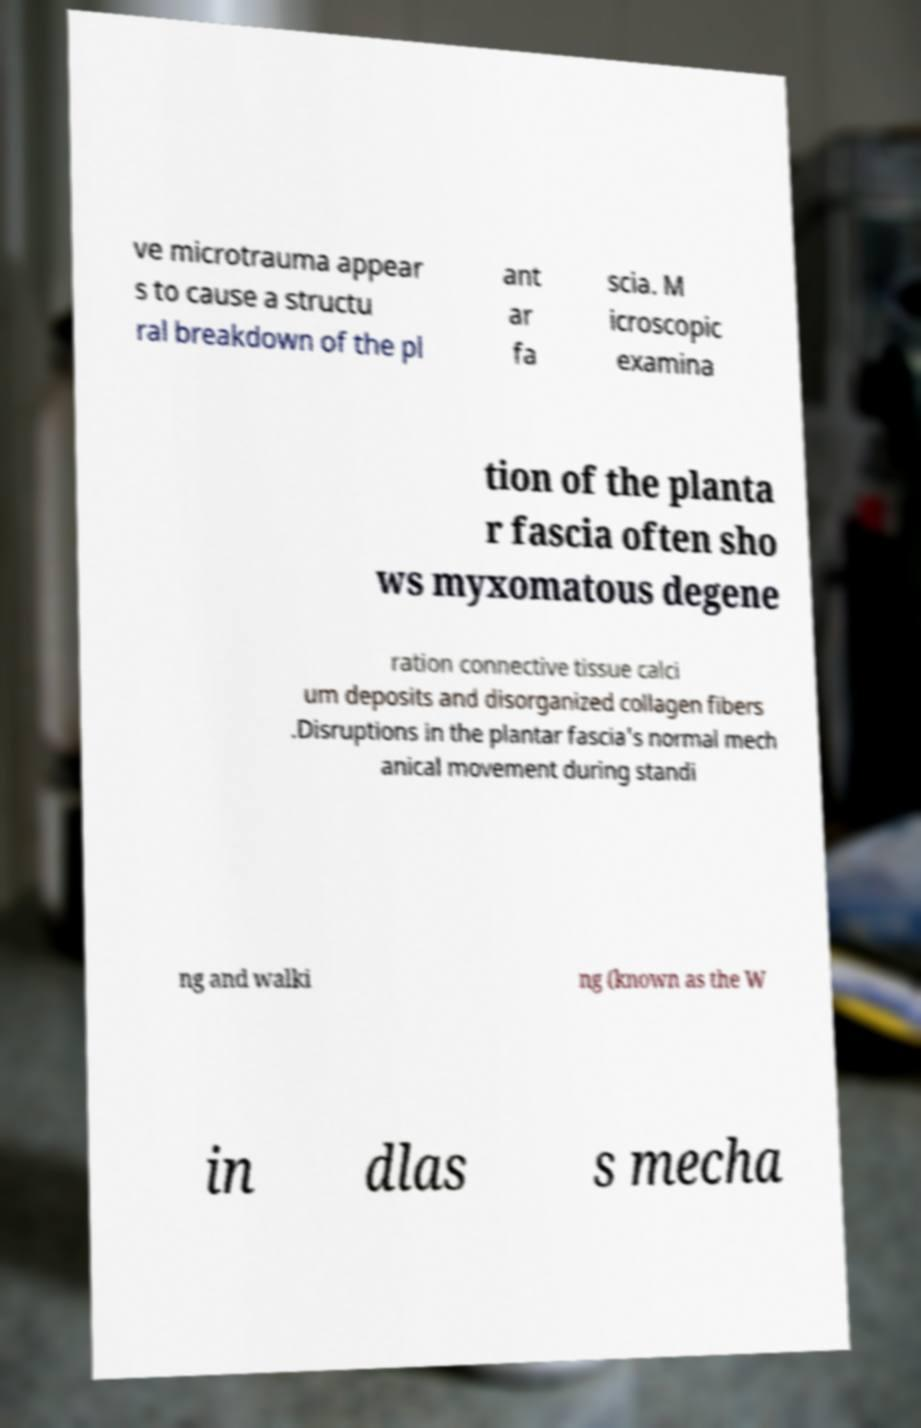Can you read and provide the text displayed in the image?This photo seems to have some interesting text. Can you extract and type it out for me? ve microtrauma appear s to cause a structu ral breakdown of the pl ant ar fa scia. M icroscopic examina tion of the planta r fascia often sho ws myxomatous degene ration connective tissue calci um deposits and disorganized collagen fibers .Disruptions in the plantar fascia's normal mech anical movement during standi ng and walki ng (known as the W in dlas s mecha 